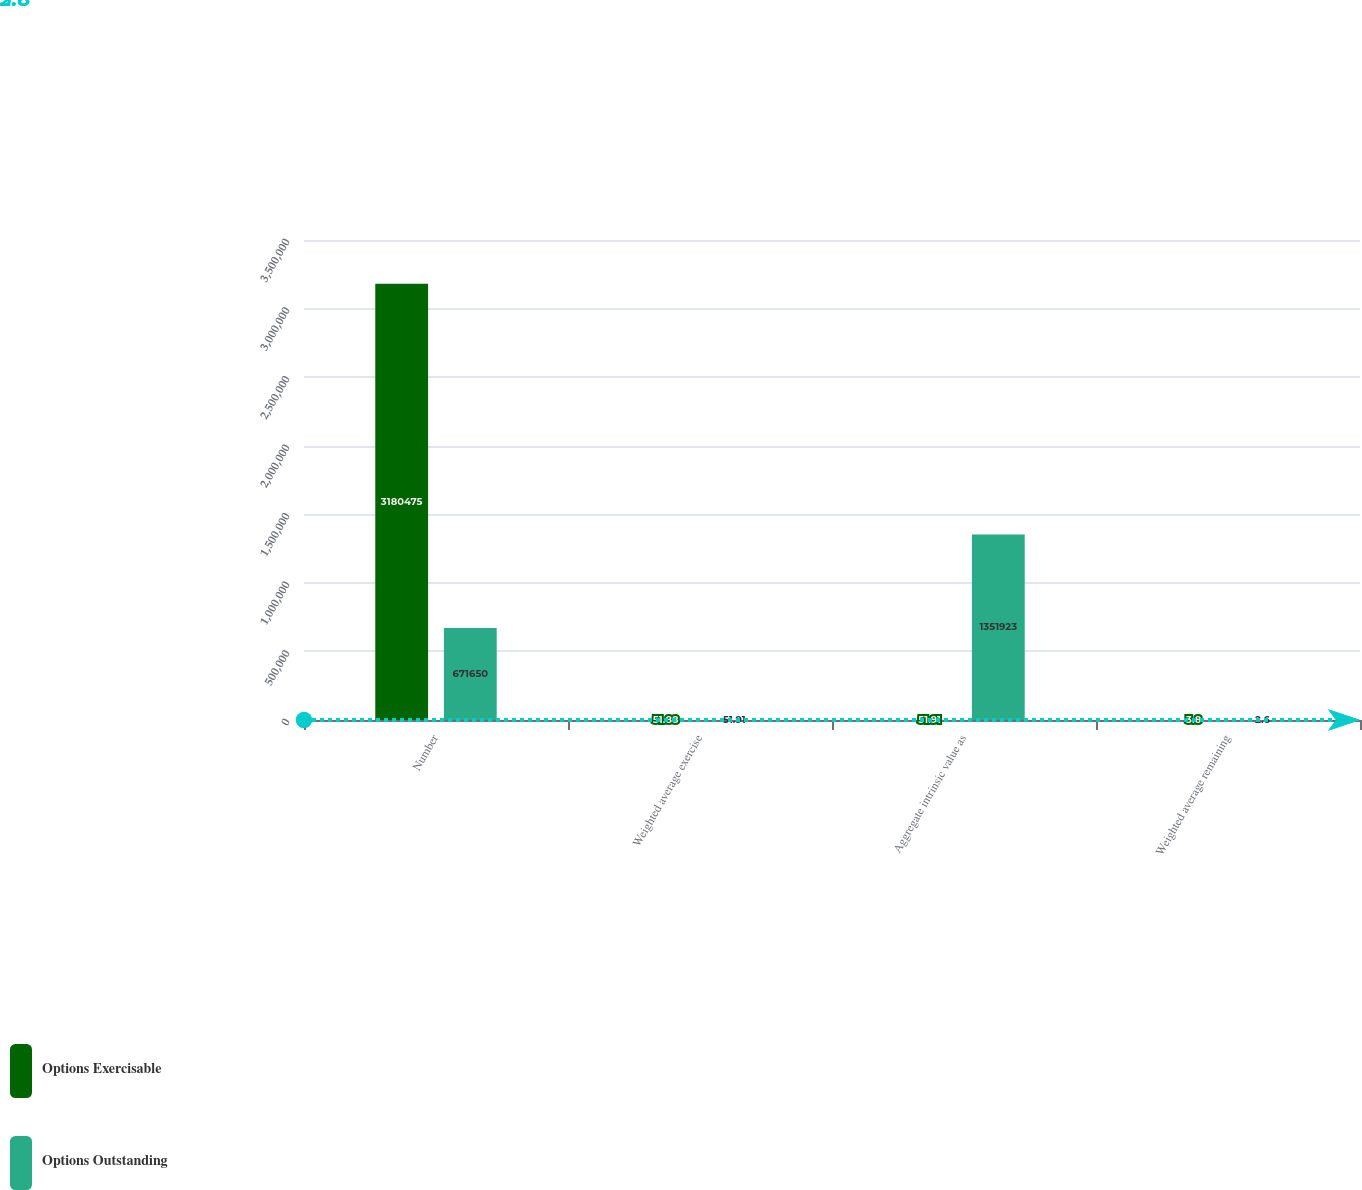<chart> <loc_0><loc_0><loc_500><loc_500><stacked_bar_chart><ecel><fcel>Number<fcel>Weighted average exercise<fcel>Aggregate intrinsic value as<fcel>Weighted average remaining<nl><fcel>Options Exercisable<fcel>3.18048e+06<fcel>51.88<fcel>51.91<fcel>3.8<nl><fcel>Options Outstanding<fcel>671650<fcel>51.91<fcel>1.35192e+06<fcel>2.6<nl></chart> 